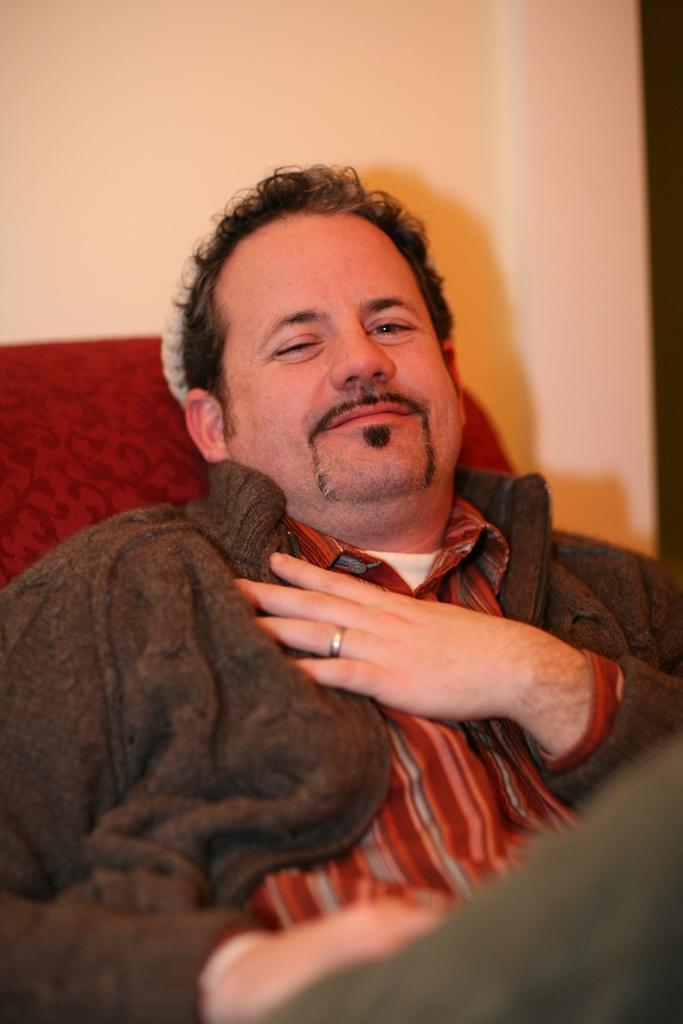How would you summarize this image in a sentence or two? In this image there is one person sitting at bottom of this image. there is a sofa at left side of this image which is in red color and there is a wall in the background. 